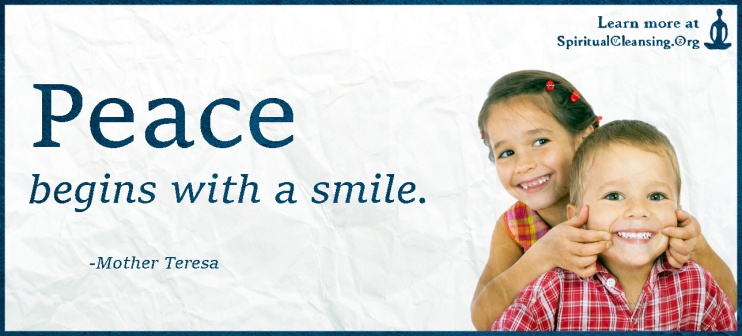Explore the significance of the children making peace signs in this image. The gesture of the children making peace signs is deeply symbolic. In the context of the message 'Peace begins with a smile,' it emphasizes the role of individual actions in fostering global harmony. The peace sign is universally recognized as a symbol of harmony, non-violence, and goodwill, aligning perfectly with the quote from Mother Teresa. By featuring young children, the image evokes a sense of inherent innocence and the natural inclination towards peace, suggesting that these values are universal and can be taught and spread from a young age. 